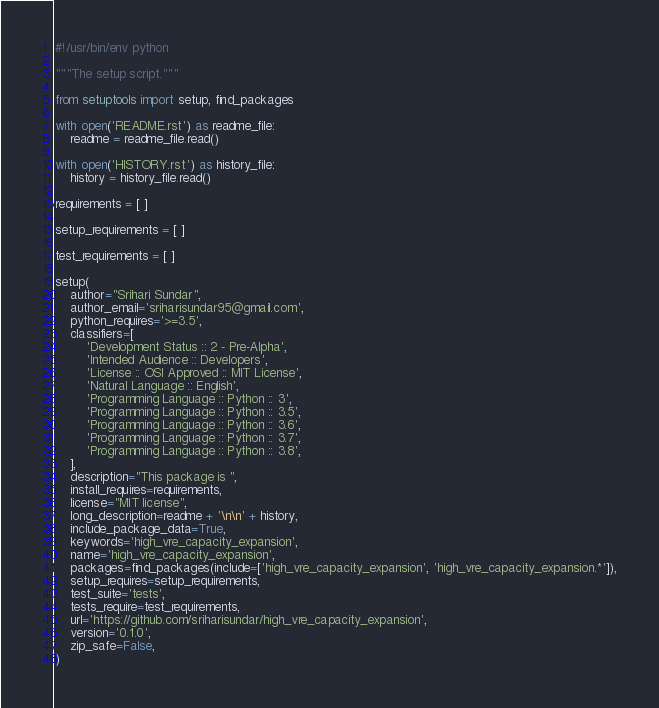<code> <loc_0><loc_0><loc_500><loc_500><_Python_>#!/usr/bin/env python

"""The setup script."""

from setuptools import setup, find_packages

with open('README.rst') as readme_file:
    readme = readme_file.read()

with open('HISTORY.rst') as history_file:
    history = history_file.read()

requirements = [ ]

setup_requirements = [ ]

test_requirements = [ ]

setup(
    author="Srihari Sundar",
    author_email='sriharisundar95@gmail.com',
    python_requires='>=3.5',
    classifiers=[
        'Development Status :: 2 - Pre-Alpha',
        'Intended Audience :: Developers',
        'License :: OSI Approved :: MIT License',
        'Natural Language :: English',
        'Programming Language :: Python :: 3',
        'Programming Language :: Python :: 3.5',
        'Programming Language :: Python :: 3.6',
        'Programming Language :: Python :: 3.7',
        'Programming Language :: Python :: 3.8',
    ],
    description="This package is ",
    install_requires=requirements,
    license="MIT license",
    long_description=readme + '\n\n' + history,
    include_package_data=True,
    keywords='high_vre_capacity_expansion',
    name='high_vre_capacity_expansion',
    packages=find_packages(include=['high_vre_capacity_expansion', 'high_vre_capacity_expansion.*']),
    setup_requires=setup_requirements,
    test_suite='tests',
    tests_require=test_requirements,
    url='https://github.com/sriharisundar/high_vre_capacity_expansion',
    version='0.1.0',
    zip_safe=False,
)
</code> 